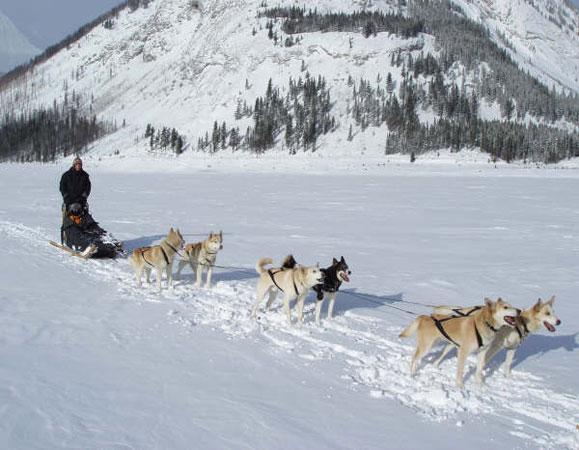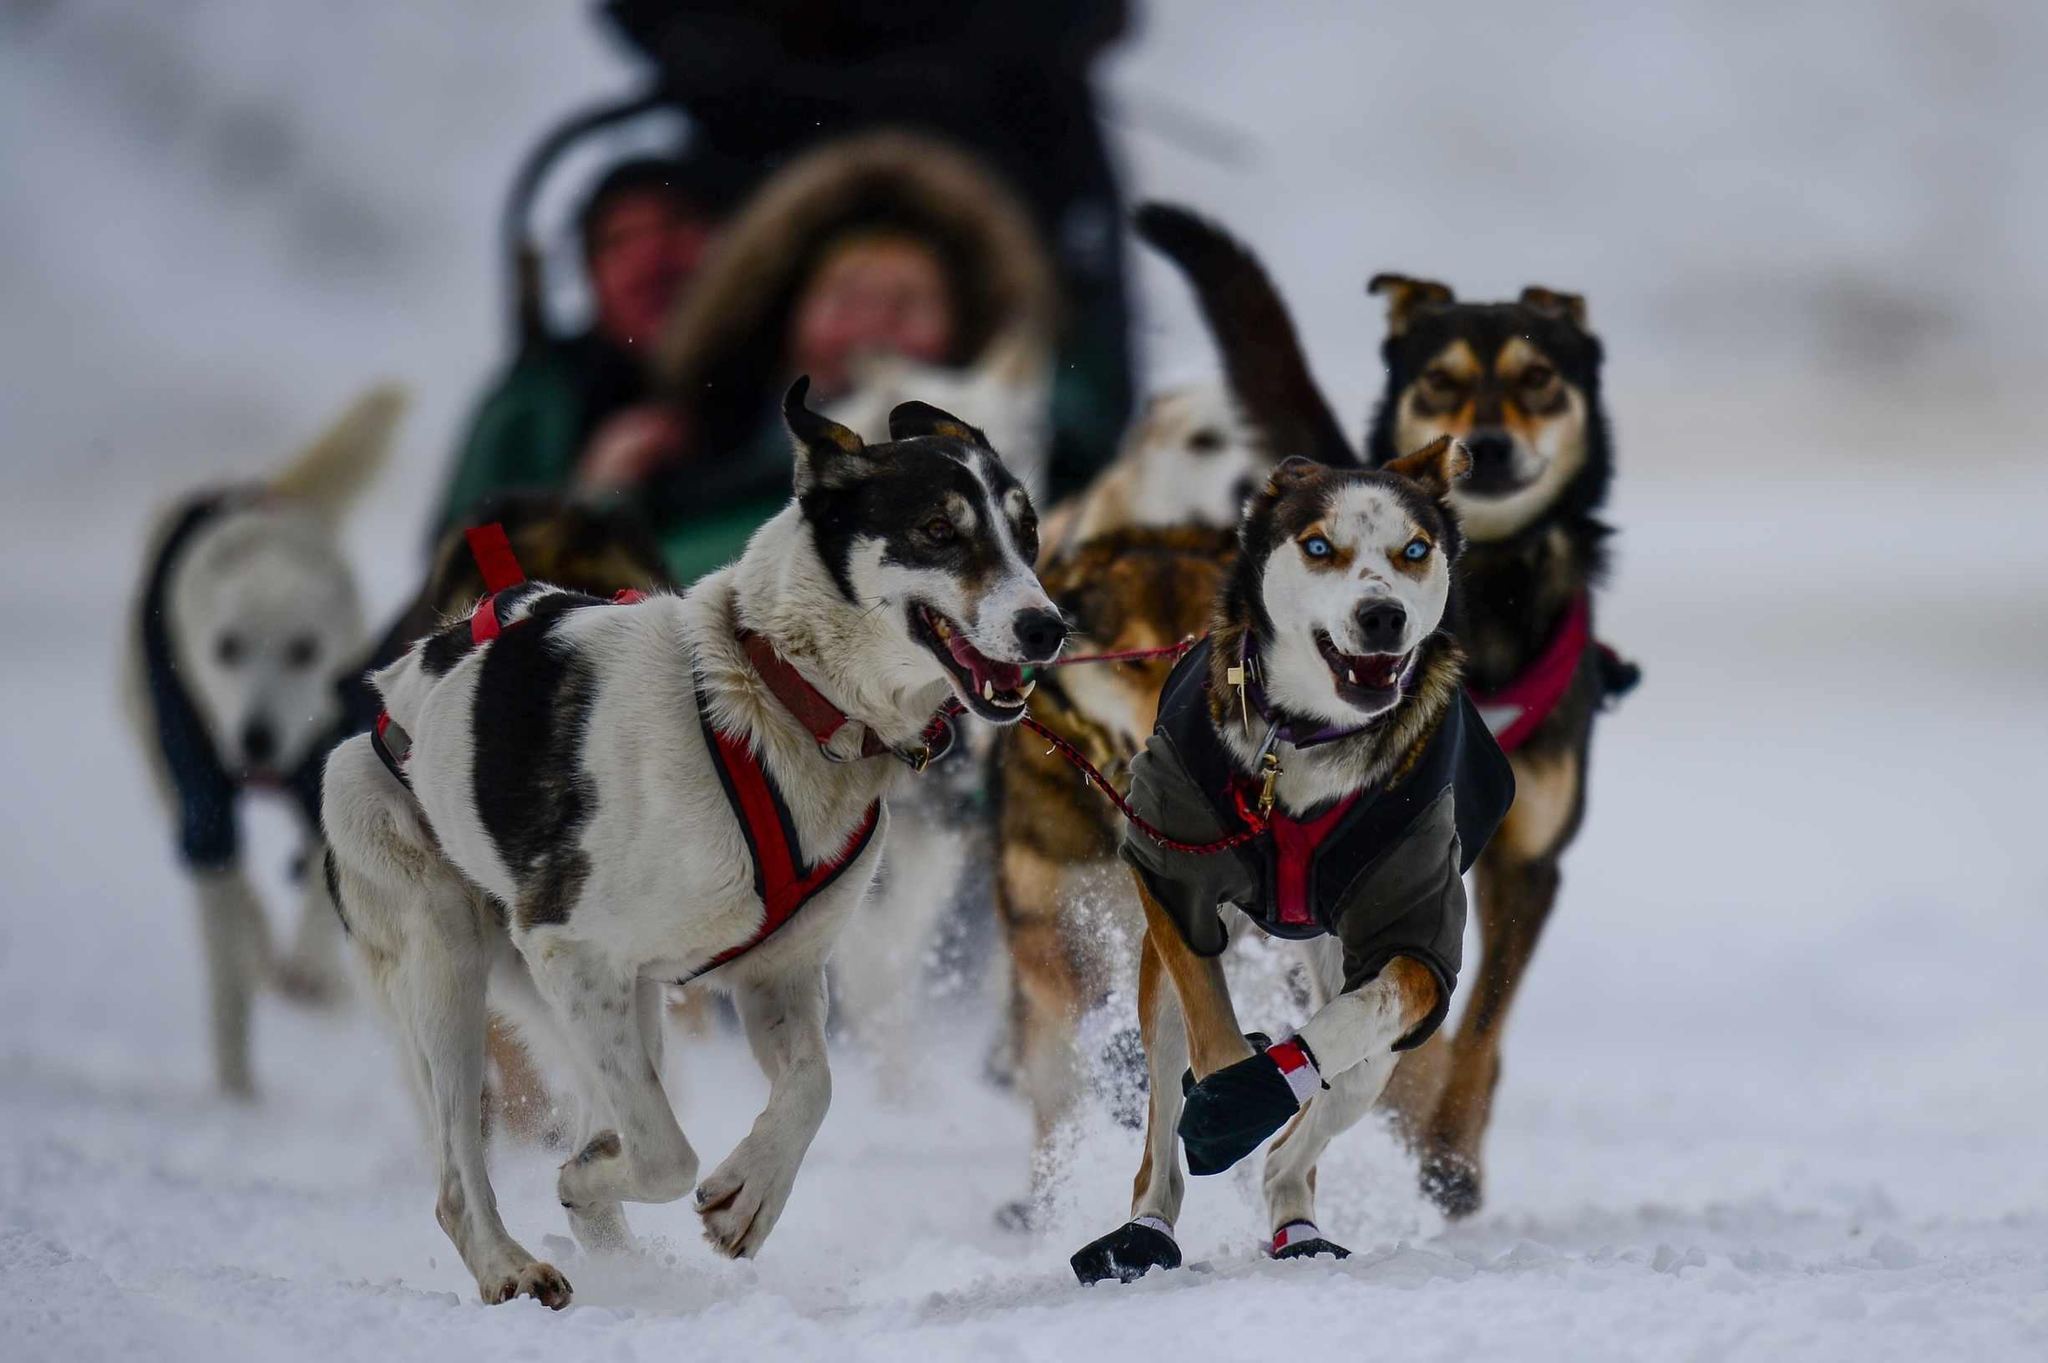The first image is the image on the left, the second image is the image on the right. Evaluate the accuracy of this statement regarding the images: "The righthand dog sled team heads straight toward the camera, and the lefthand team heads at a diagonal to the right.". Is it true? Answer yes or no. Yes. The first image is the image on the left, the second image is the image on the right. Analyze the images presented: Is the assertion "The left image contains no more than six sled dogs." valid? Answer yes or no. Yes. 